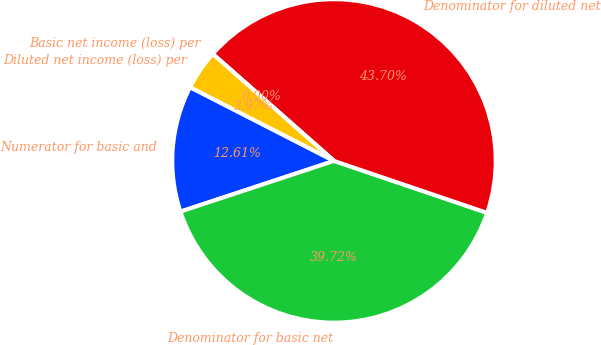Convert chart to OTSL. <chart><loc_0><loc_0><loc_500><loc_500><pie_chart><fcel>Numerator for basic and<fcel>Denominator for basic net<fcel>Denominator for diluted net<fcel>Basic net income (loss) per<fcel>Diluted net income (loss) per<nl><fcel>12.61%<fcel>39.72%<fcel>43.7%<fcel>0.0%<fcel>3.97%<nl></chart> 